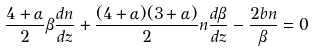Convert formula to latex. <formula><loc_0><loc_0><loc_500><loc_500>\frac { 4 + \alpha } { 2 } \beta \frac { d n } { d z } + \frac { ( 4 + \alpha ) ( 3 + \alpha ) } { 2 } n \frac { d \beta } { d z } - \frac { 2 b n } { \beta } = 0</formula> 